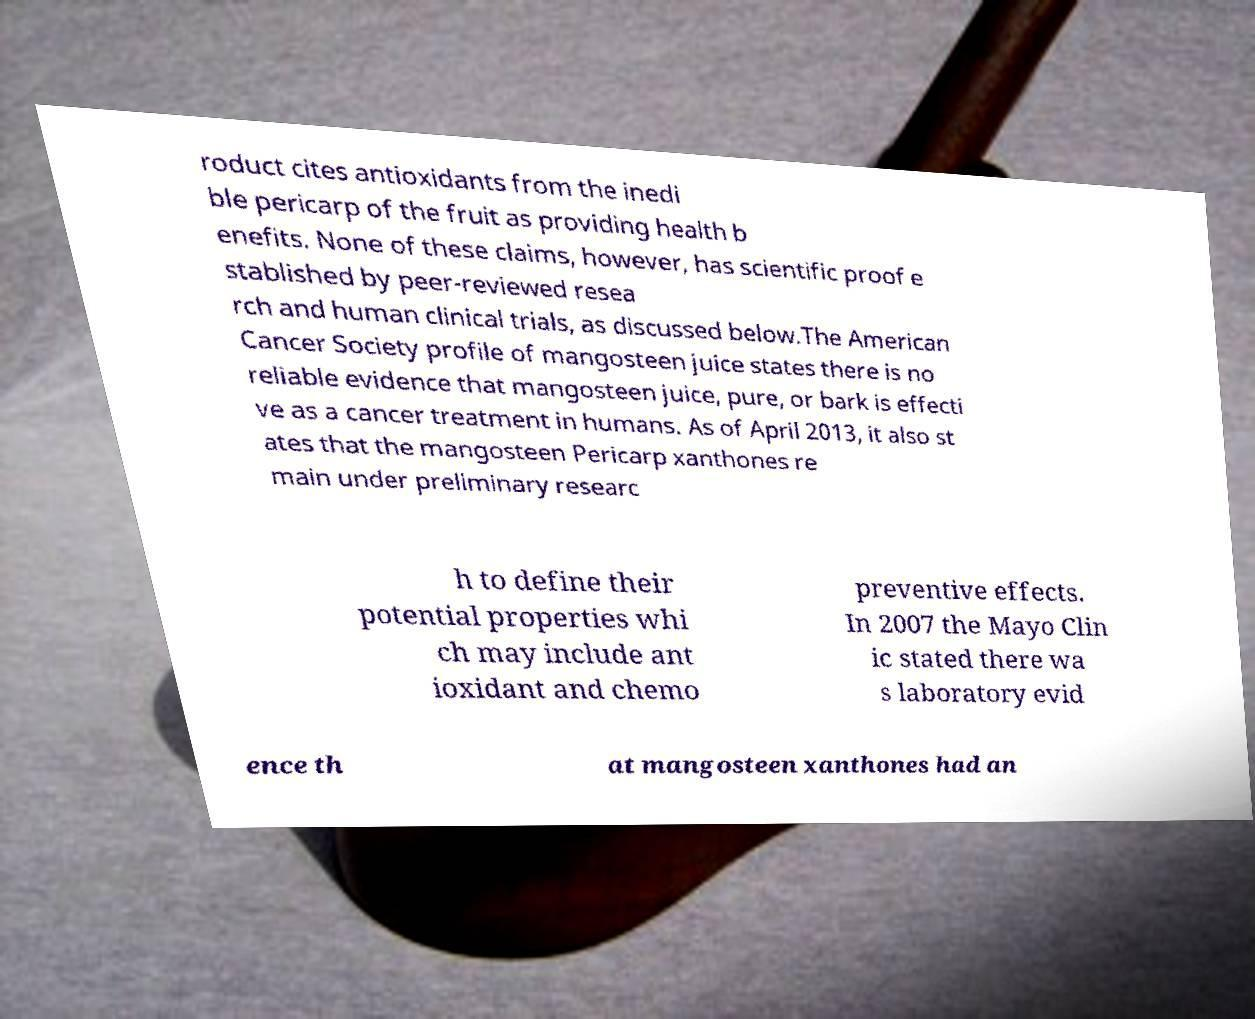For documentation purposes, I need the text within this image transcribed. Could you provide that? roduct cites antioxidants from the inedi ble pericarp of the fruit as providing health b enefits. None of these claims, however, has scientific proof e stablished by peer-reviewed resea rch and human clinical trials, as discussed below.The American Cancer Society profile of mangosteen juice states there is no reliable evidence that mangosteen juice, pure, or bark is effecti ve as a cancer treatment in humans. As of April 2013, it also st ates that the mangosteen Pericarp xanthones re main under preliminary researc h to define their potential properties whi ch may include ant ioxidant and chemo preventive effects. In 2007 the Mayo Clin ic stated there wa s laboratory evid ence th at mangosteen xanthones had an 